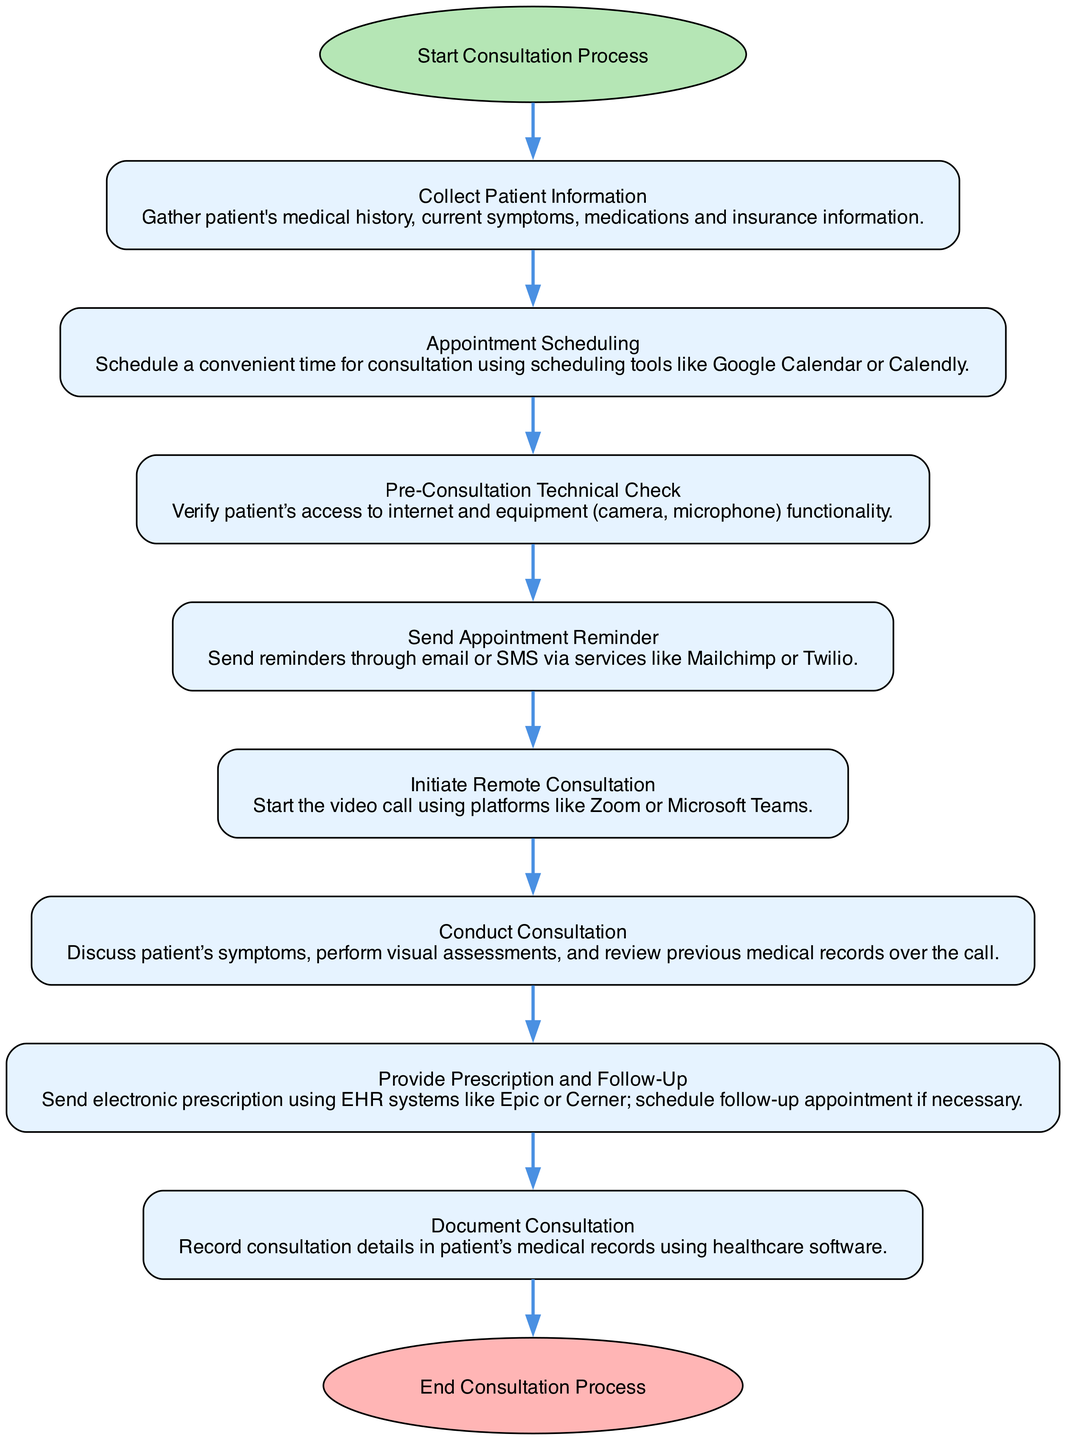What is the first step in the consultation process? The diagram shows that the first element is labeled "Start Consultation Process," indicating that this is the first step to initiate the flow.
Answer: Start Consultation Process How many tasks are involved in managing a remote patient consultation? By examining the diagram, we count the tasks listed from "Collect Patient Information" to "Document Consultation." There are a total of seven tasks.
Answer: Seven What tool is suggested for scheduling appointments? The diagram specifies "Google Calendar or Calendly" as the tools for scheduling, providing two alternatives for users.
Answer: Google Calendar or Calendly What happens immediately after collecting patient information? The flowchart indicates that once "Collect Patient Information" is completed, the next task is "Appointment Scheduling," outlining the sequential order of tasks.
Answer: Appointment Scheduling What step follows the "Pre-Consultation Technical Check"? According to the flowchart, after performing the "Pre-Consultation Technical Check," the next step is to "Send Appointment Reminder," showing the continued process.
Answer: Send Appointment Reminder How many end events are depicted in the diagram? The diagram features only one end event, labeled "End Consultation Process," which signifies the conclusion of the consultation flow.
Answer: One Which phase involves verifying the patient’s access to internet and equipment? The flow shows that "Pre-Consultation Technical Check" is the specific phase where the verification of internet and equipment access takes place.
Answer: Pre-Consultation Technical Check In terms of sequence, what precedes the documentation of the consultation session? Before "Document Consultation," the prior step in the diagram is "Provide Prescription and Follow-Up," establishing the order in which these actions occur.
Answer: Provide Prescription and Follow-Up What is the final action in the remote patient consultation process? The diagram clearly indicates that the last step, concluding the entire process, is "End Consultation Process," marking the completion of all tasks.
Answer: End Consultation Process 